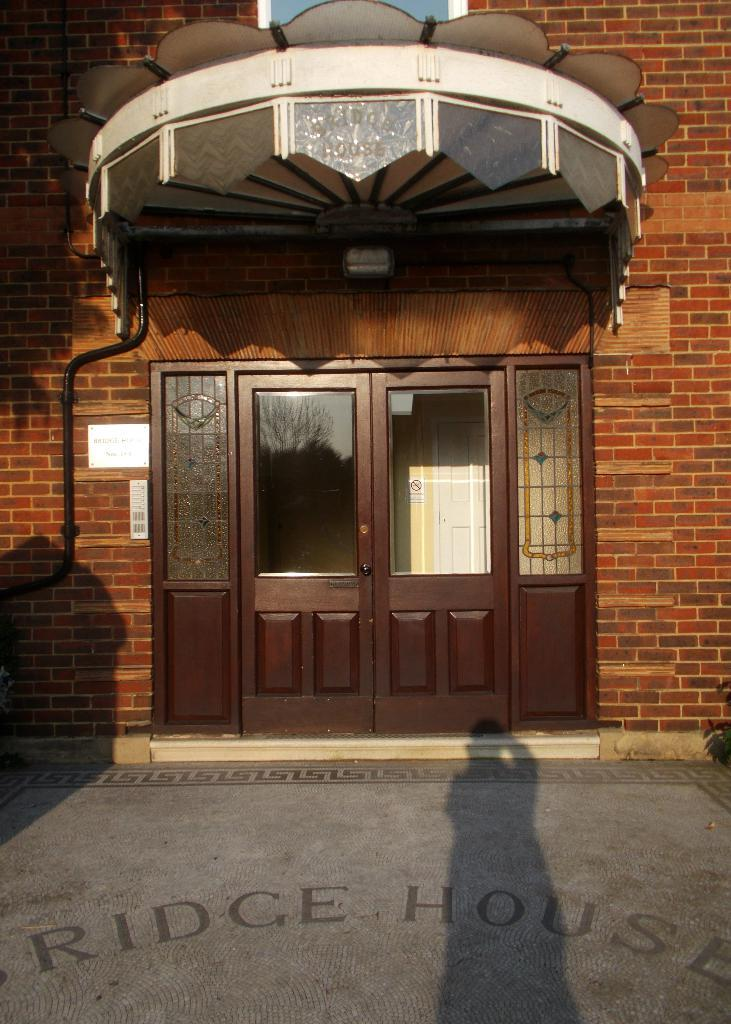What is the main architectural feature visible in the image? There is a door in the image. What other structural elements can be seen in the image? There are walls in the image. What type of industrial element is present in the image? There is a pipeline in the image. What surface is visible in the image? There is a floor in the image. What can be observed on the floor in the image? There is a person's shadow on the floor in the image. Can you tell me how many giraffes are visible in the image? There are no giraffes present in the image. What type of writing instrument is the person holding in the image? There is no person holding any writing instrument in the image; only a shadow is visible. 